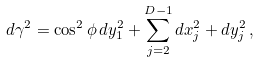Convert formula to latex. <formula><loc_0><loc_0><loc_500><loc_500>d \gamma ^ { 2 } = \cos ^ { 2 } \phi \, d y _ { 1 } ^ { 2 } + \sum _ { j = 2 } ^ { D - 1 } d x _ { j } ^ { 2 } + d y _ { j } ^ { 2 } \, ,</formula> 